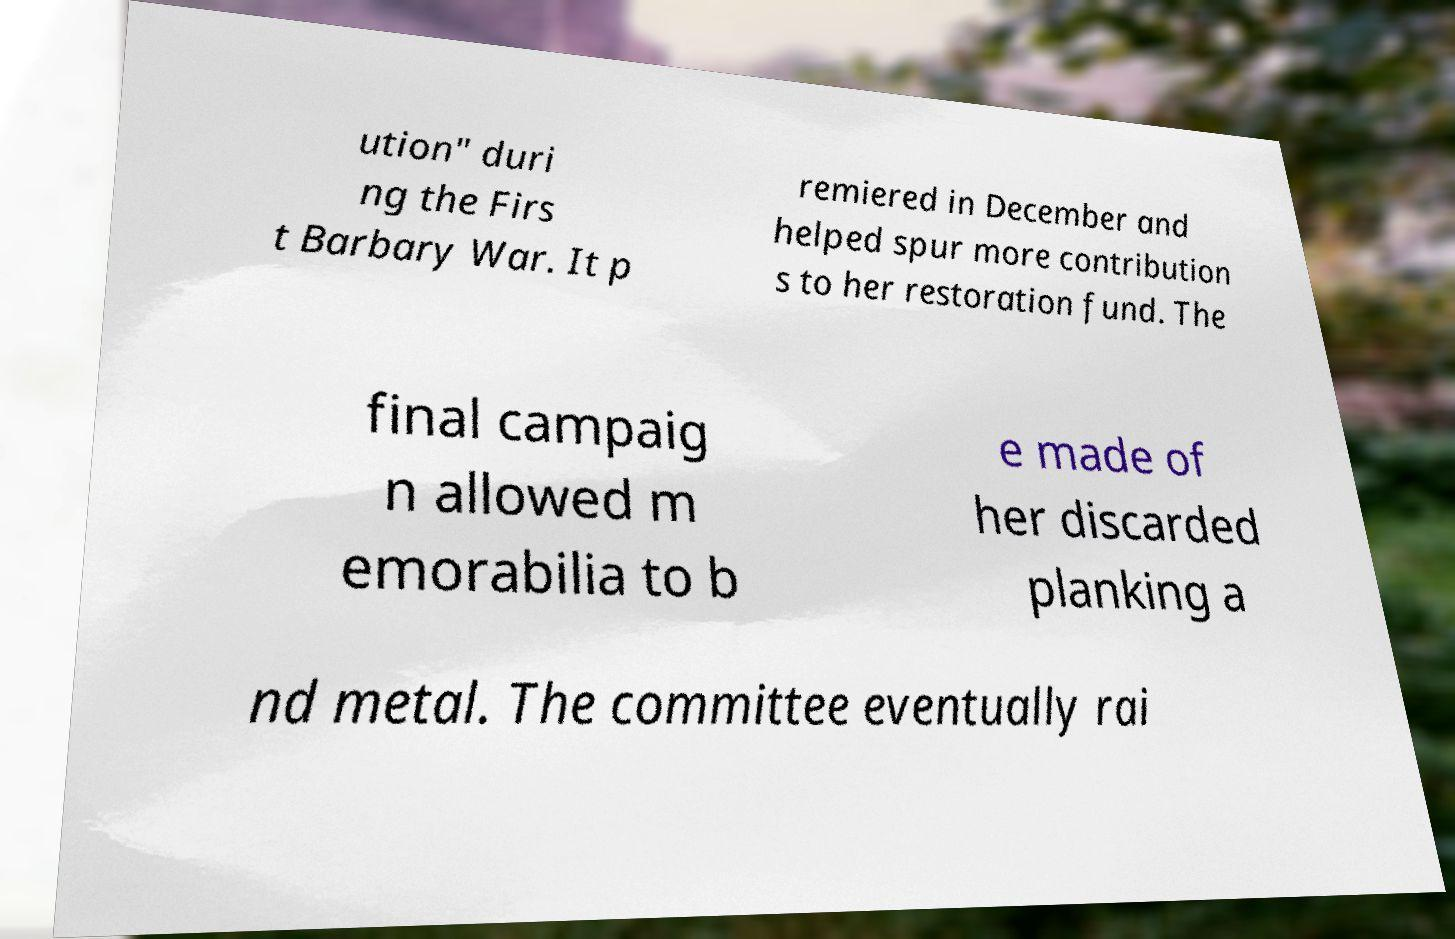For documentation purposes, I need the text within this image transcribed. Could you provide that? ution" duri ng the Firs t Barbary War. It p remiered in December and helped spur more contribution s to her restoration fund. The final campaig n allowed m emorabilia to b e made of her discarded planking a nd metal. The committee eventually rai 